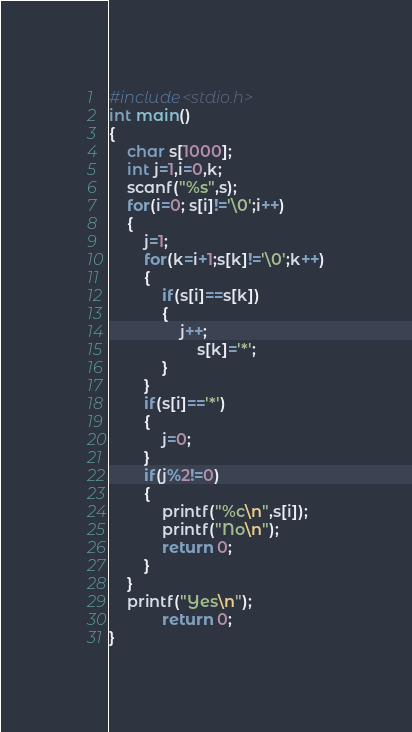Convert code to text. <code><loc_0><loc_0><loc_500><loc_500><_C_>#include<stdio.h>
int main()
{
    char s[1000];
    int j=1,i=0,k;
    scanf("%s",s);
    for(i=0; s[i]!='\0';i++)
    {
        j=1;
        for(k=i+1;s[k]!='\0';k++)
        {
            if(s[i]==s[k])
            {
                j++;
                    s[k]='*';
            }
        }
        if(s[i]=='*')
        {
            j=0;
        }
        if(j%2!=0)
        {
            printf("%c\n",s[i]);
            printf("No\n");
            return 0;
        }
    }
    printf("Yes\n");
            return 0;
}
</code> 